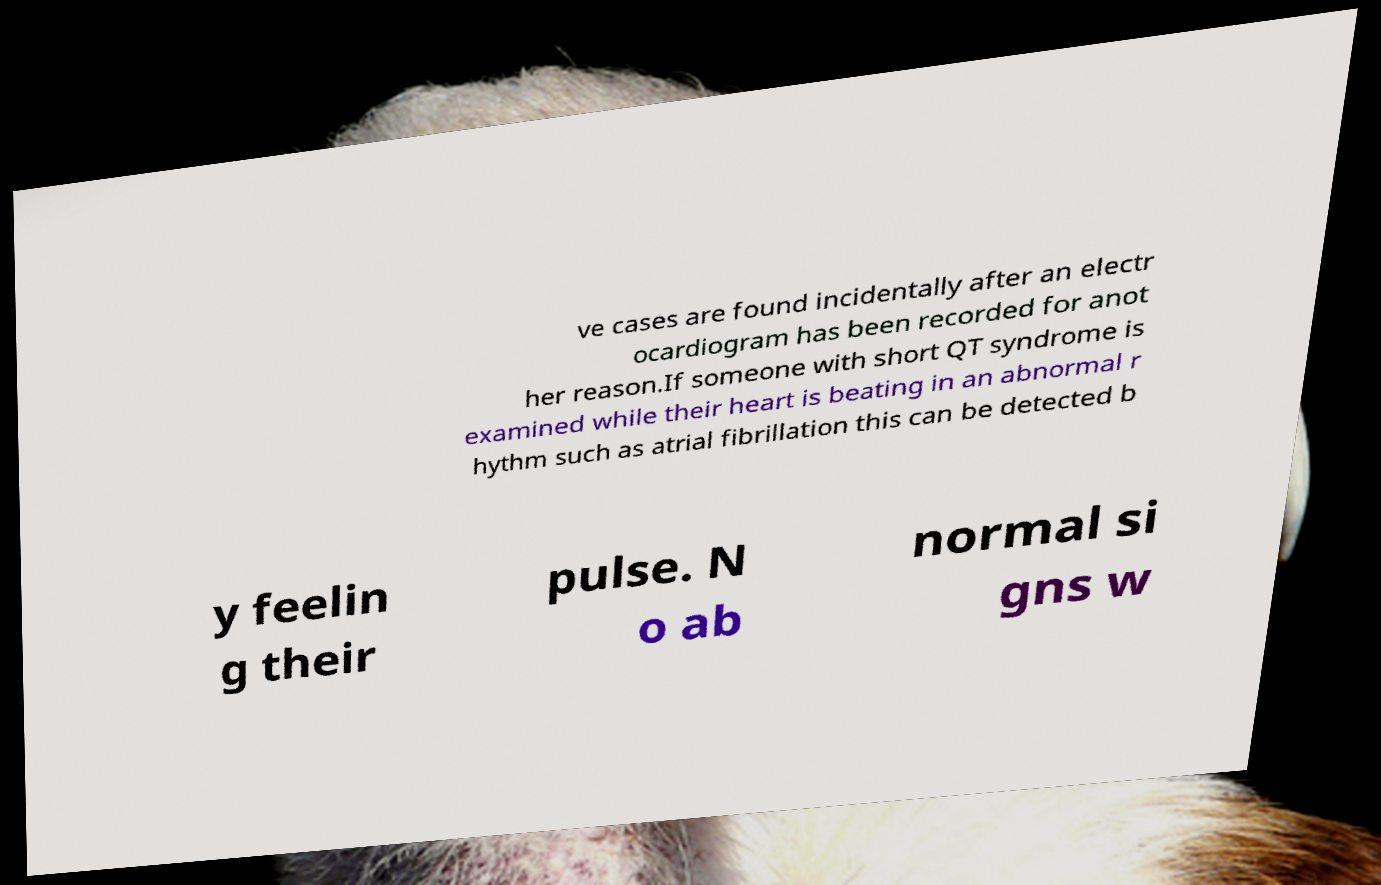For documentation purposes, I need the text within this image transcribed. Could you provide that? ve cases are found incidentally after an electr ocardiogram has been recorded for anot her reason.If someone with short QT syndrome is examined while their heart is beating in an abnormal r hythm such as atrial fibrillation this can be detected b y feelin g their pulse. N o ab normal si gns w 